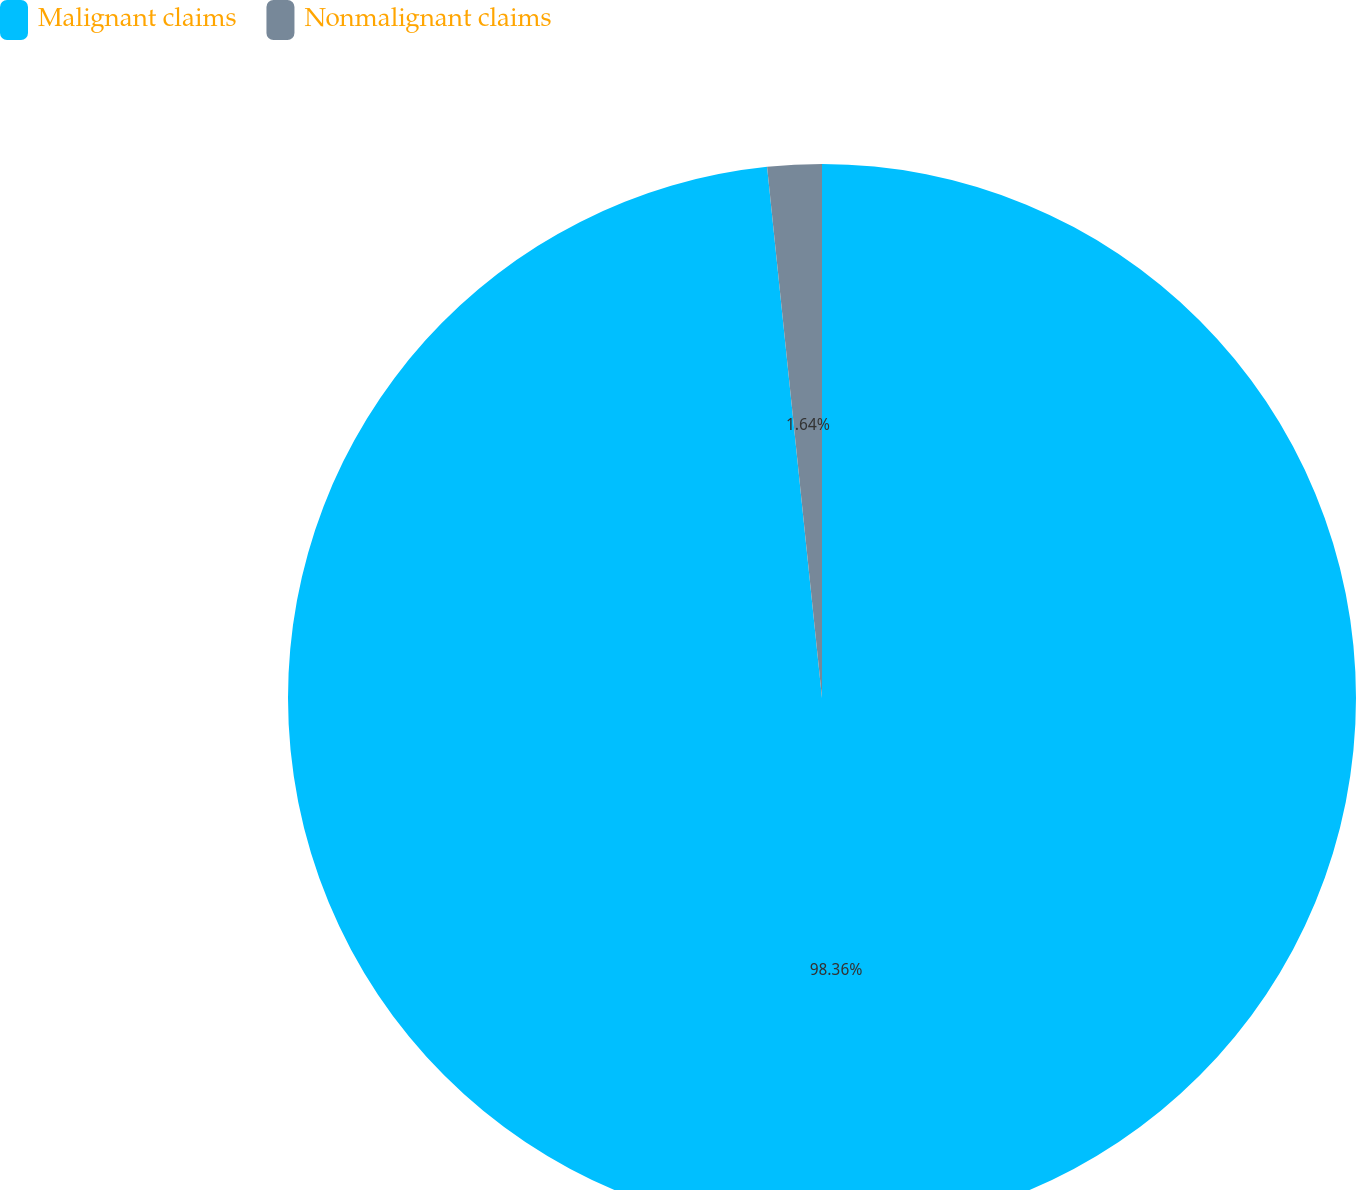Convert chart. <chart><loc_0><loc_0><loc_500><loc_500><pie_chart><fcel>Malignant claims<fcel>Nonmalignant claims<nl><fcel>98.36%<fcel>1.64%<nl></chart> 